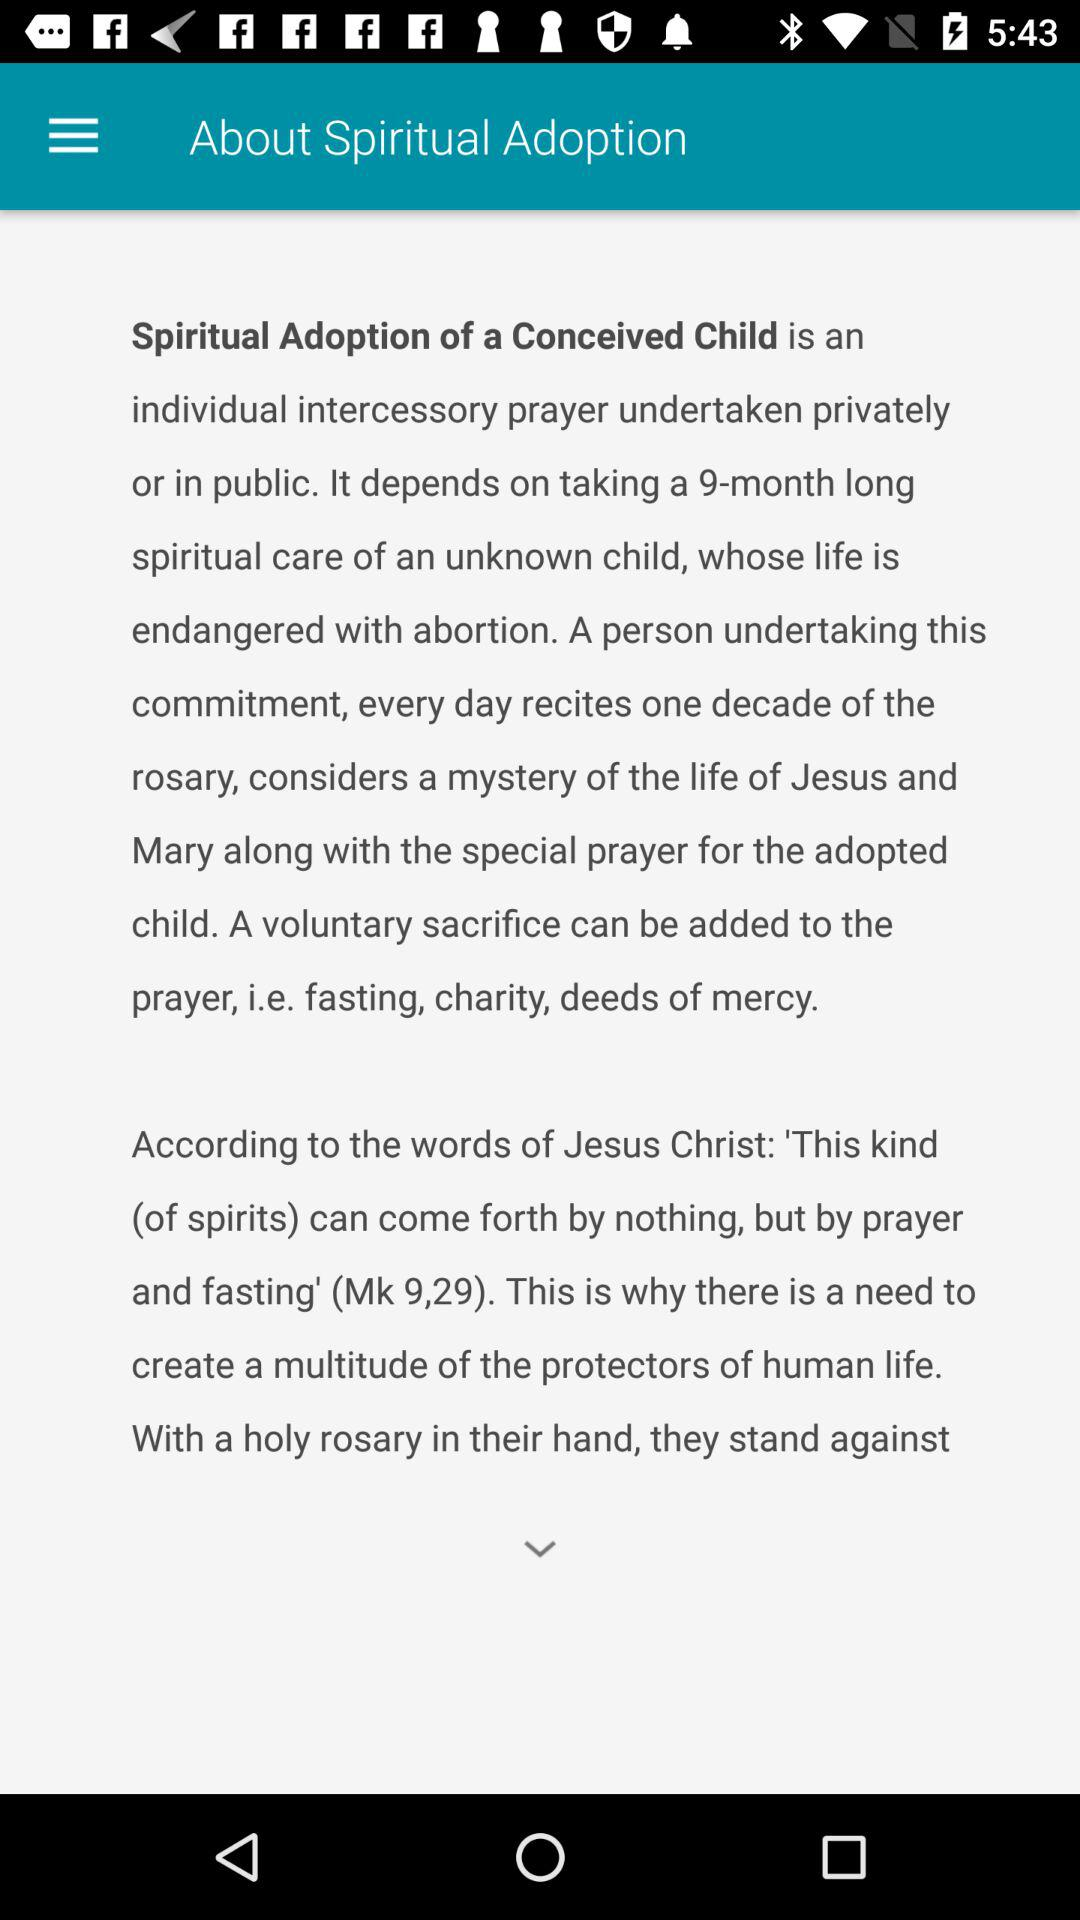What is Spiritual Adoption of a conceived child? Spiritual Adoption of a Conceived Child is an individual intercessory prayer undertaken privately or in public. It depends on taking a 9-month long spiritual care of an unknown child, whose life is endangered with abortion. A person undertaking this commitment, every day recites one decade of the rosary, considers a mystery of the life of Jesus and Mary along with the special prayer for the adopted child. A voluntary sacrifice can be added to the prayer, i.e. fasting, charity, deeds of mercy. 